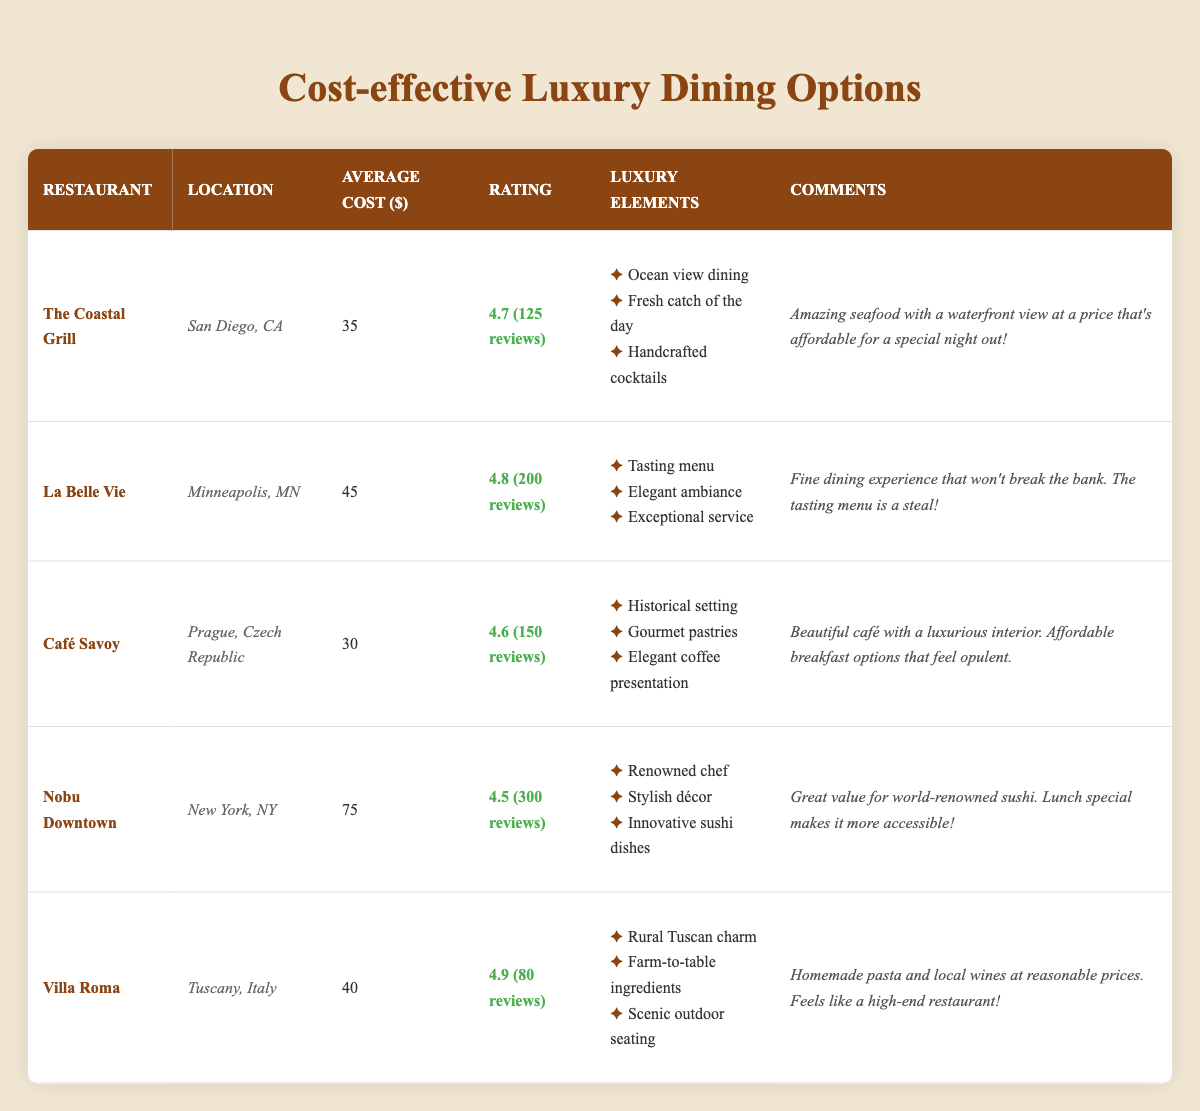What is the average cost of dining at The Coastal Grill? The average cost for dining at The Coastal Grill is listed as 35 dollars in the table.
Answer: 35 What is the rating of Café Savoy? Café Savoy has a rating of 4.6 along with 150 reviews, as indicated in the table.
Answer: 4.6 Which restaurant has the highest rating and what is it? To find the highest rating, we compare the ratings: The Coastal Grill (4.7), La Belle Vie (4.8), Café Savoy (4.6), Nobu Downtown (4.5), and Villa Roma (4.9). La Belle Vie has the highest rating at 4.8.
Answer: 4.8 Is there a restaurant with an average cost less than 40 dollars? The table shows that Café Savoy averages 30 dollars and The Coastal Grill averages 35 dollars. Both are less than 40 dollars, so yes, there are restaurants with an average cost below that.
Answer: Yes Calculate the average cost of dining at all listed restaurants. Adding the average costs: 35 + 45 + 30 + 75 + 40 = 225. There are 5 restaurants, so the average cost is calculated as 225/5 = 45.
Answer: 45 Does Nobu Downtown have any luxury elements mentioned in the reviews? The table lists several luxury elements for Nobu Downtown: renowned chef, stylish décor, and innovative sushi dishes, confirming that it does have luxury elements.
Answer: Yes What is the total review count for all restaurants? To find the total review count, we sum the counts: 125 + 200 + 150 + 300 + 80 = 855. Thus, the total review count is 855.
Answer: 855 Which restaurant is located in Tuscany, Italy, and what is its average cost? The restaurant in Tuscany, Italy, is Villa Roma, and its average cost is 40 dollars as shown in the table.
Answer: Villa Roma, 40 Which restaurant offers the most affordable average dinner option while having a good rating? Among the options, Café Savoy has the lowest average cost at 30 dollars and a rating of 4.6, making it the most affordable with a good rating.
Answer: Café Savoy, 30 